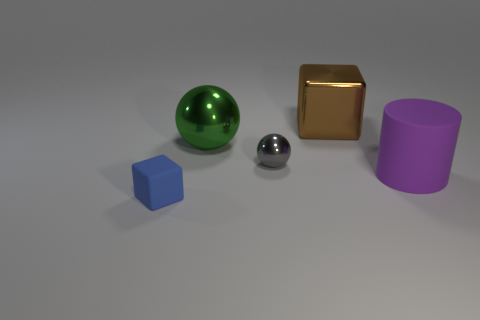Can you describe the shapes and their colors in the image? Certainly! In the image, we see a green sphere, a gold-colored cube, a small silver sphere, a blue cube, and a purple cylinder. Each shape has a distinct, smooth surface and they are all placed on a neutral grey surface under diffused lighting. 